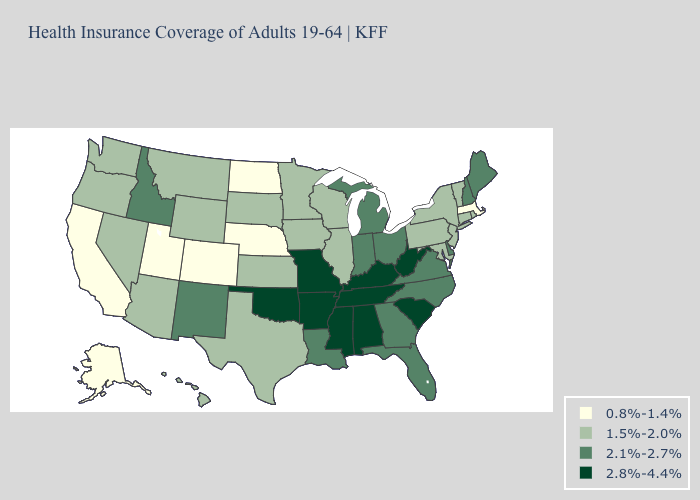What is the value of Michigan?
Give a very brief answer. 2.1%-2.7%. What is the highest value in the USA?
Concise answer only. 2.8%-4.4%. Name the states that have a value in the range 2.1%-2.7%?
Quick response, please. Delaware, Florida, Georgia, Idaho, Indiana, Louisiana, Maine, Michigan, New Hampshire, New Mexico, North Carolina, Ohio, Virginia. Which states have the highest value in the USA?
Answer briefly. Alabama, Arkansas, Kentucky, Mississippi, Missouri, Oklahoma, South Carolina, Tennessee, West Virginia. What is the value of Montana?
Quick response, please. 1.5%-2.0%. What is the lowest value in the Northeast?
Concise answer only. 0.8%-1.4%. What is the value of Massachusetts?
Keep it brief. 0.8%-1.4%. Does Indiana have the same value as Vermont?
Give a very brief answer. No. Name the states that have a value in the range 2.8%-4.4%?
Be succinct. Alabama, Arkansas, Kentucky, Mississippi, Missouri, Oklahoma, South Carolina, Tennessee, West Virginia. What is the value of Kansas?
Answer briefly. 1.5%-2.0%. What is the lowest value in the Northeast?
Give a very brief answer. 0.8%-1.4%. What is the value of Arizona?
Answer briefly. 1.5%-2.0%. What is the value of North Carolina?
Give a very brief answer. 2.1%-2.7%. Among the states that border Connecticut , does Massachusetts have the highest value?
Write a very short answer. No. What is the value of New Mexico?
Answer briefly. 2.1%-2.7%. 